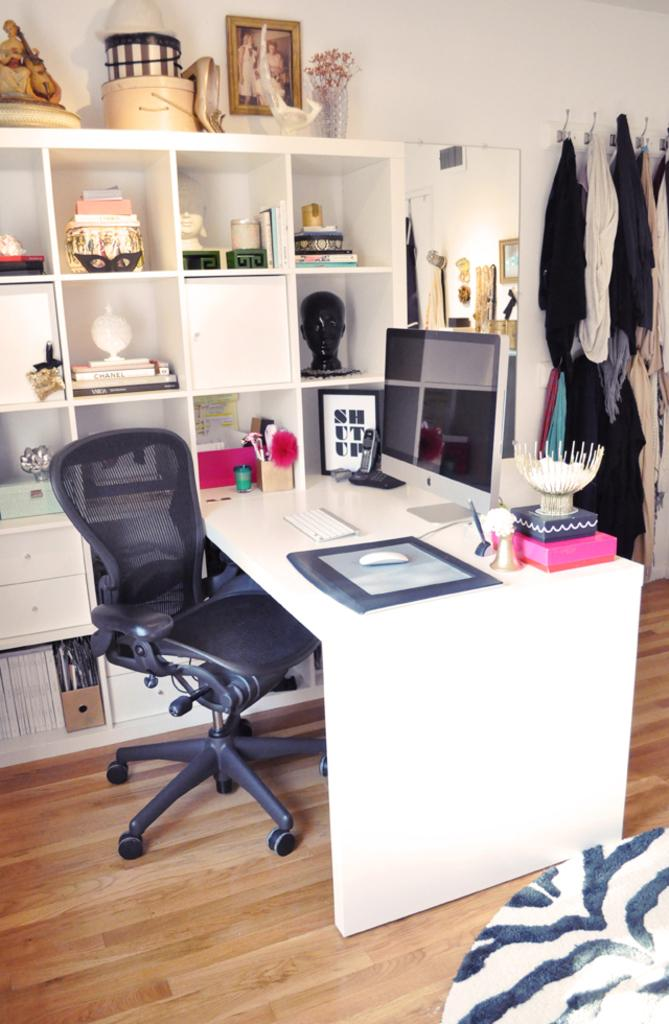<image>
Create a compact narrative representing the image presented. A frame depicts the phrase shut up and sits on a desk. 